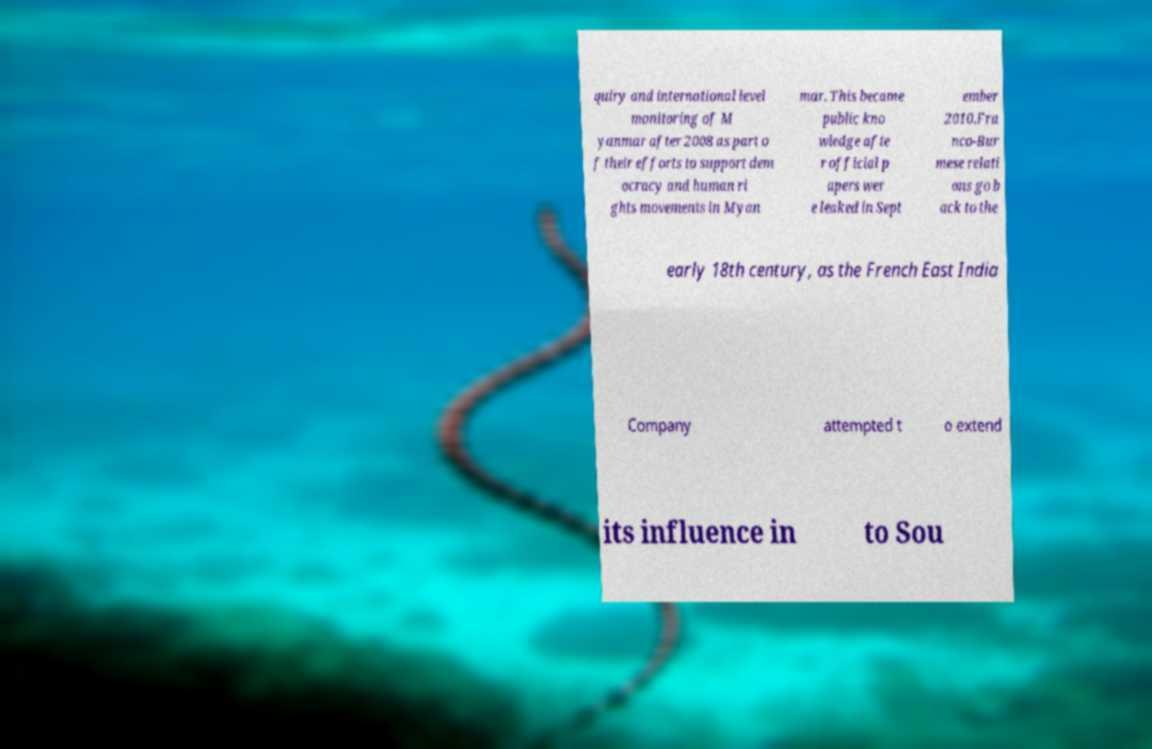I need the written content from this picture converted into text. Can you do that? quiry and international level monitoring of M yanmar after 2008 as part o f their efforts to support dem ocracy and human ri ghts movements in Myan mar. This became public kno wledge afte r official p apers wer e leaked in Sept ember 2010.Fra nco-Bur mese relati ons go b ack to the early 18th century, as the French East India Company attempted t o extend its influence in to Sou 